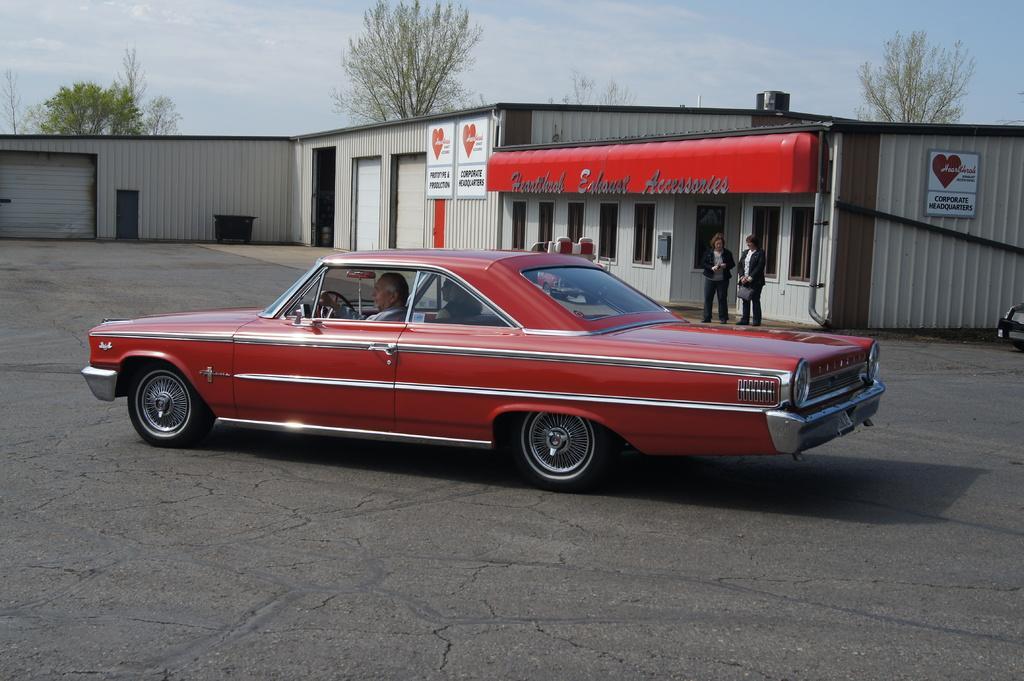How would you summarize this image in a sentence or two? In this image there is a car at bottom of this image and there are some shelters in middle of this image and there are some trees in the background and there is a sky at top of this image. There are two persons standing at right side of this image and there are two persons sitting in to the car which is in middle of this image. 